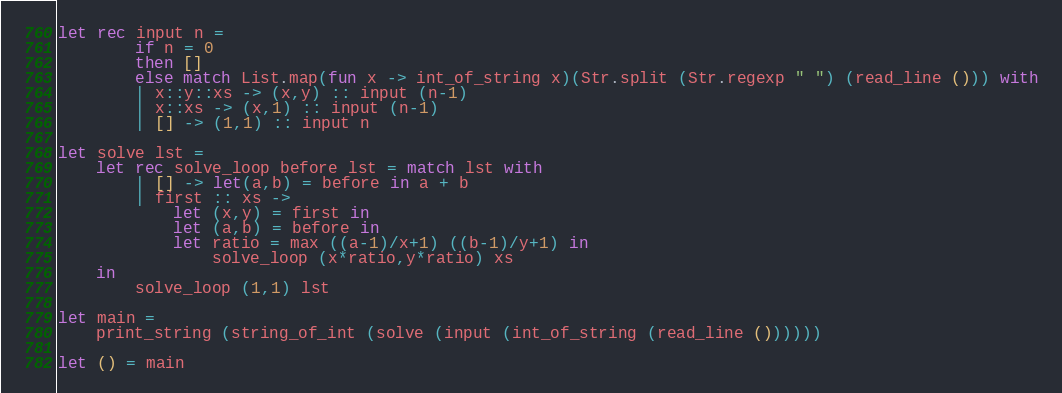<code> <loc_0><loc_0><loc_500><loc_500><_OCaml_>let rec input n =
		if n = 0
		then []
		else match List.map(fun x -> int_of_string x)(Str.split (Str.regexp " ") (read_line ())) with
		| x::y::xs -> (x,y) :: input (n-1)
		| x::xs -> (x,1) :: input (n-1)
		| [] -> (1,1) :: input n

let solve lst =
	let rec solve_loop before lst = match lst with
		| [] -> let(a,b) = before in a + b
		| first :: xs ->
			let (x,y) = first in
			let (a,b) = before in
			let ratio = max ((a-1)/x+1) ((b-1)/y+1) in
				solve_loop (x*ratio,y*ratio) xs
	in
		solve_loop (1,1) lst
	
let main =
	print_string (string_of_int (solve (input (int_of_string (read_line ())))))

let () = main</code> 